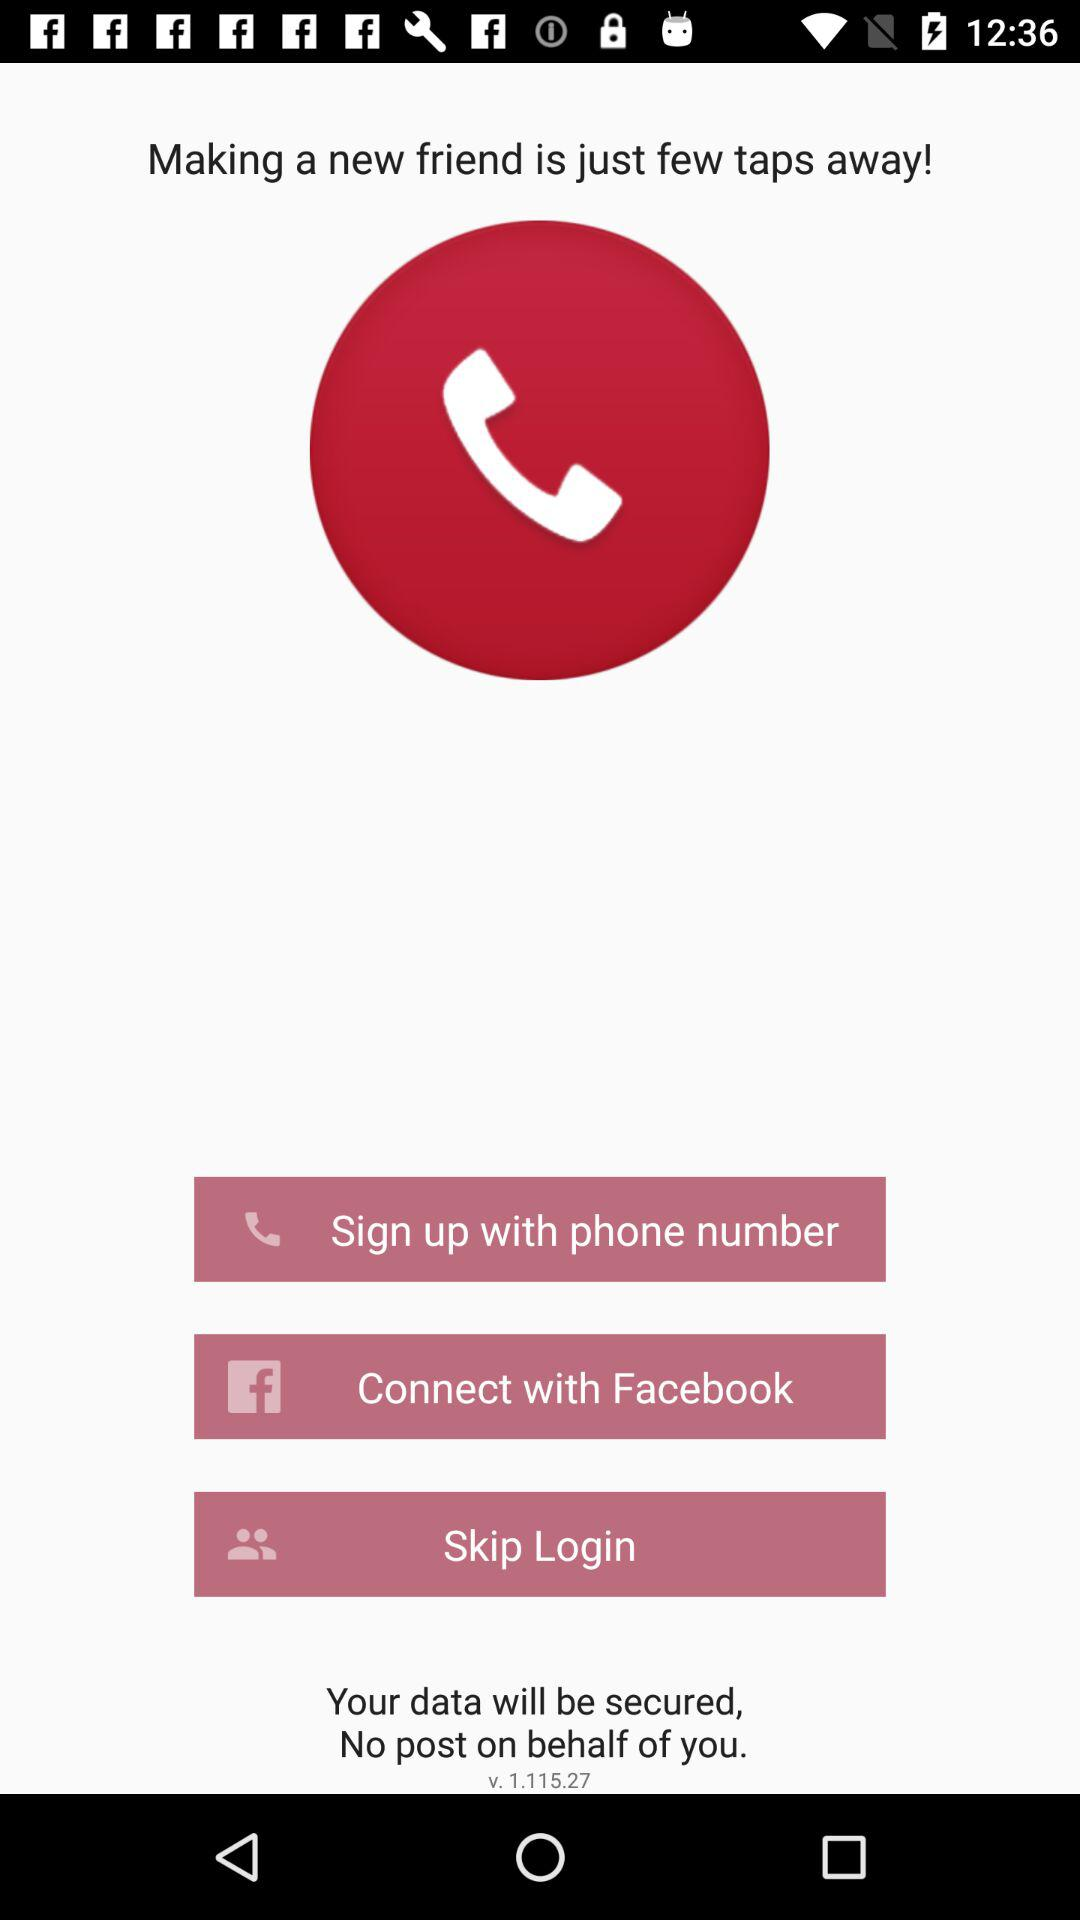What are the different login options? The different login option is "Facebook". 